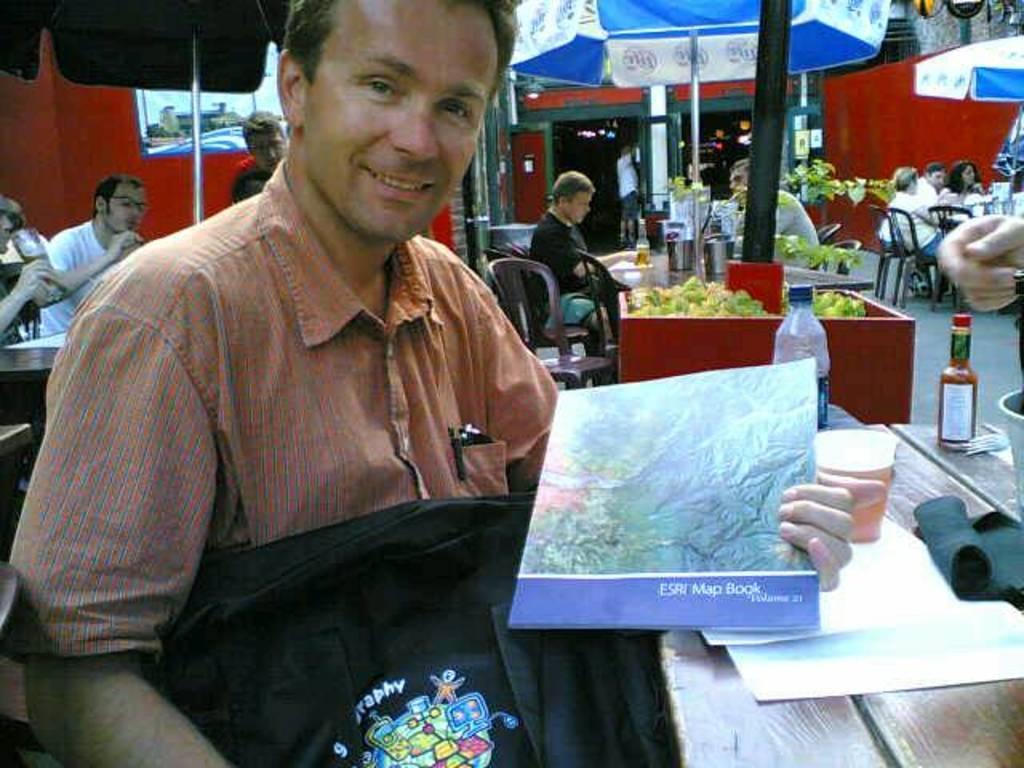Can you describe this image briefly? In this picture we can see a man holding a book and a bag. On the right side of the man, there are bottles, a cup, papers and some objects on the table. Behind the man, there are umbrellas with poles and there is a plant, a pole, building and some other objects. There are groups of people sitting on the chairs. 